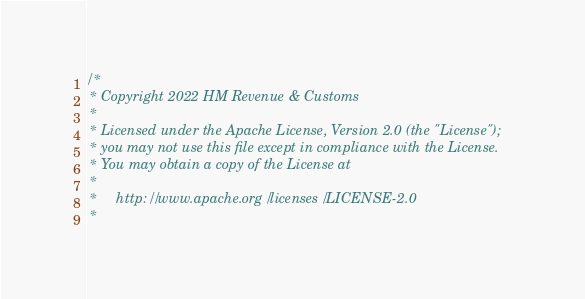<code> <loc_0><loc_0><loc_500><loc_500><_Scala_>/*
 * Copyright 2022 HM Revenue & Customs
 *
 * Licensed under the Apache License, Version 2.0 (the "License");
 * you may not use this file except in compliance with the License.
 * You may obtain a copy of the License at
 *
 *     http://www.apache.org/licenses/LICENSE-2.0
 *</code> 